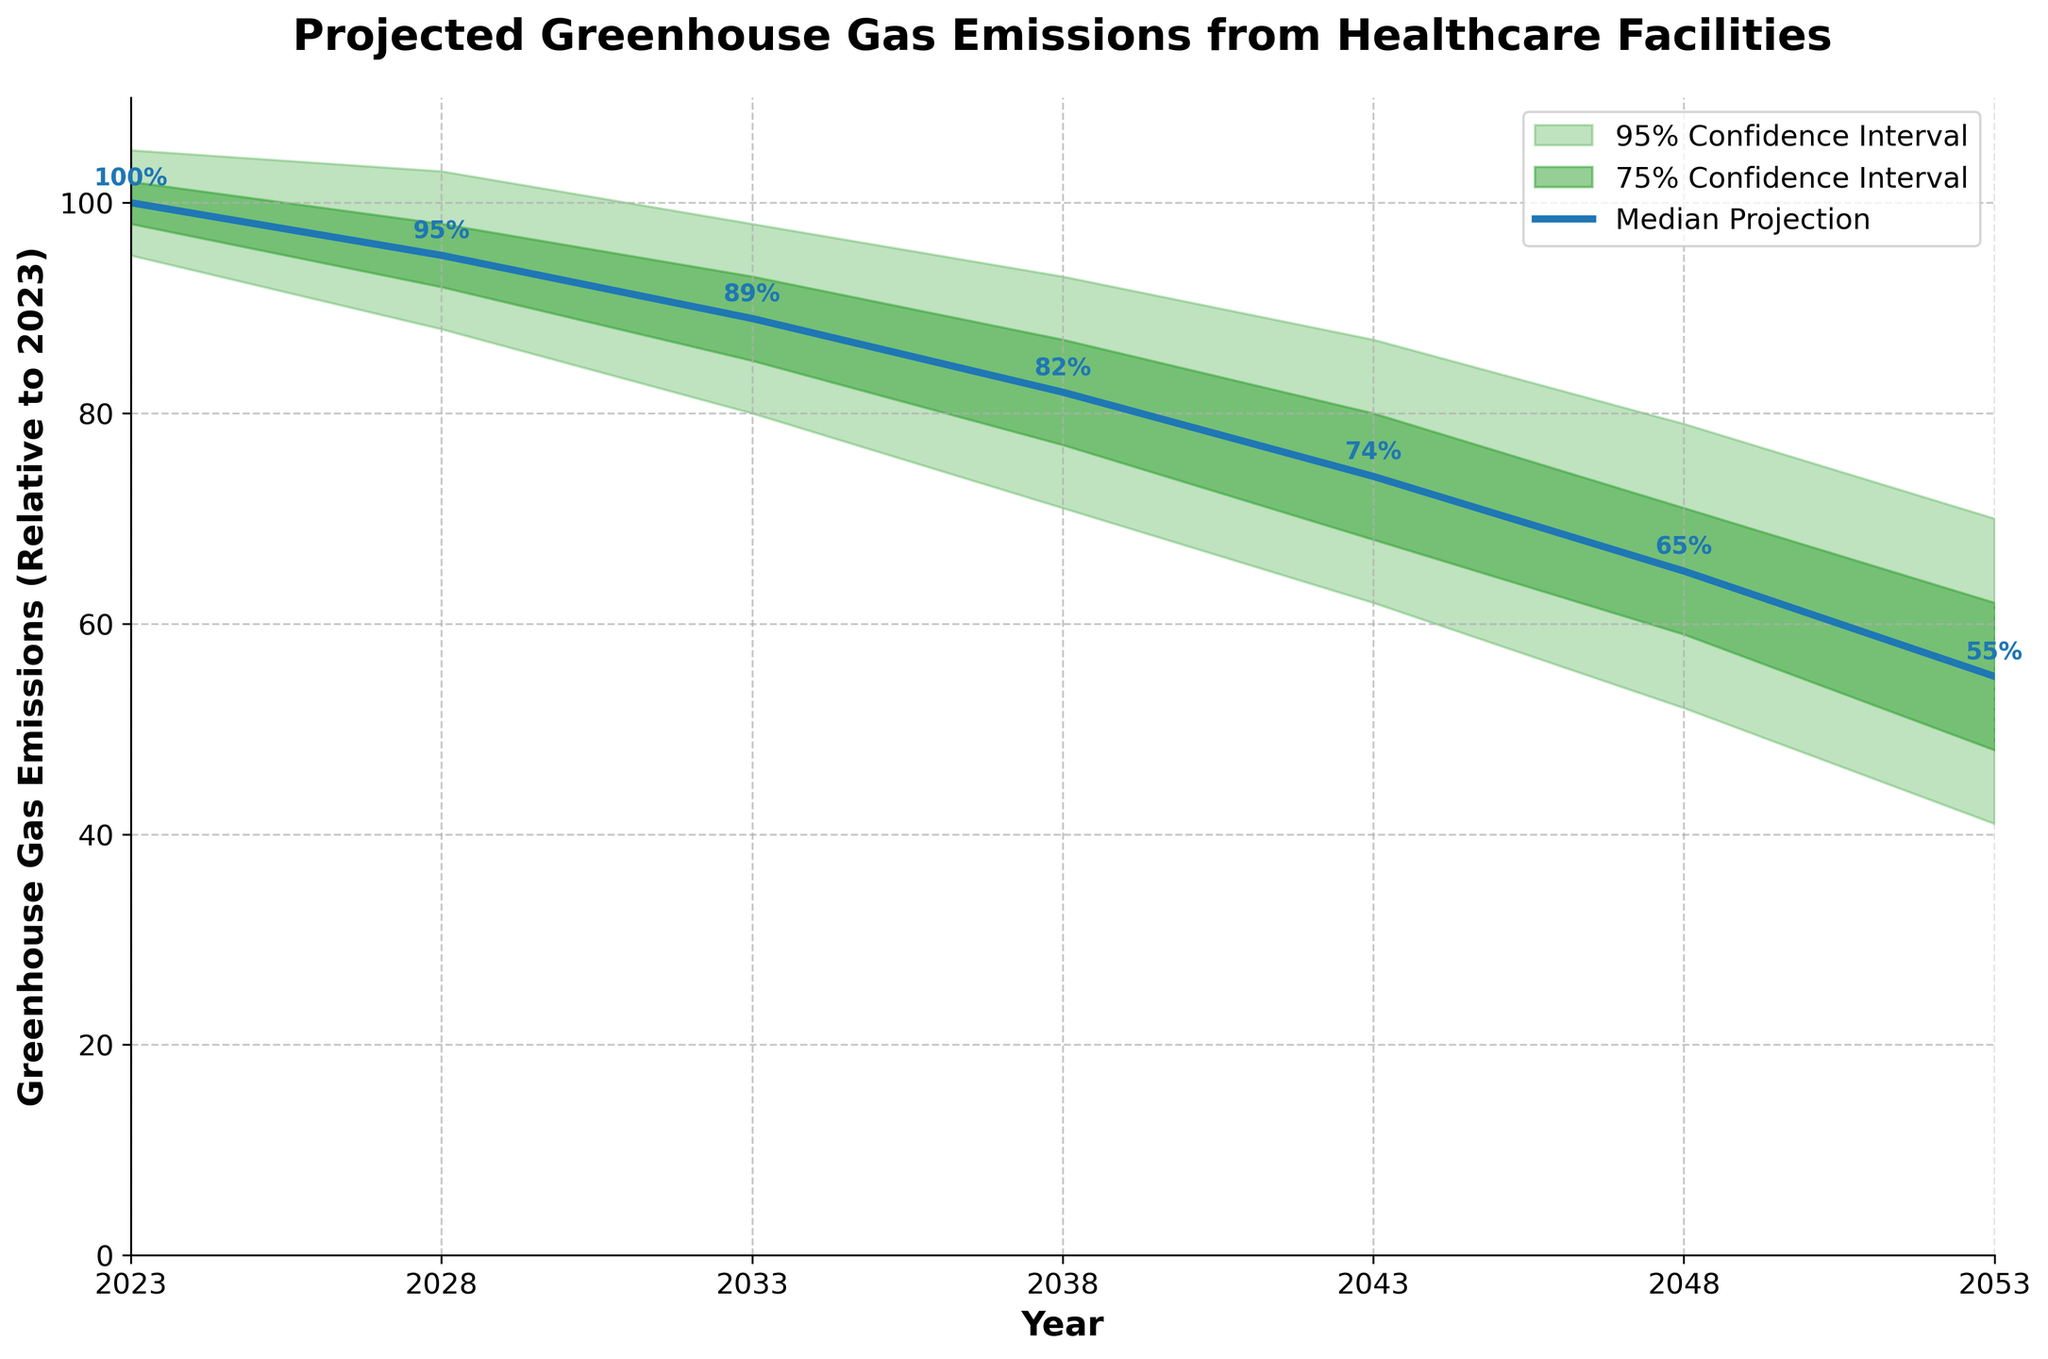How many confidence intervals are represented in the plot? The plot shows two shades of green representing the 95% and 75% confidence intervals.
Answer: 2 What is the title of the plot? The title of the plot, as indicated at the top, is "Projected Greenhouse Gas Emissions from Healthcare Facilities".
Answer: Projected Greenhouse Gas Emissions from Healthcare Facilities In which year is the median projected greenhouse gas emission the lowest? By observing the blue line representing the median projection, the lowest point on this line occurs in the year 2053.
Answer: 2053 Compare the median projected greenhouse gas emissions between 2023 and 2048. Which year has higher emissions and by how much? The median for 2023 is 100, and for 2048, it is 65. Subtracting the emissions in 2048 from 2023 we get 100 - 65. Therefore, 2023 has higher emissions by 35.
Answer: 2023 has higher emissions by 35 What is the projected range for greenhouse gas emissions in 2038 within the 95% confidence interval? The 95% confidence interval range for 2038 can be found by looking at the green shaded area. The lower bound is 71, and the upper bound is 93.
Answer: 71 to 93 By how much are the median greenhouse gas emissions expected to decrease from 2023 to 2028? The median emission in 2023 is 100, and in 2028 it is 95. The decrease is calculated as 100 - 95.
Answer: Decrease by 5 At what year does the upper bound of the 75% confidence interval first drop below 80? The value of the upper bound of the 75% confidence interval first drops below 80 in the year 2043.
Answer: 2043 How does the width of the 95% confidence interval change over the years? The width of the 95% confidence interval increases as we move further into the future, indicating increasing uncertainty.
Answer: Increases What is the range of the median projected emissions values over the entire period from 2023 to 2053? The maximum median value is 100 in 2023, and the minimum median value is 55 in 2053, giving a range of 100 - 55.
Answer: 55 to 100 